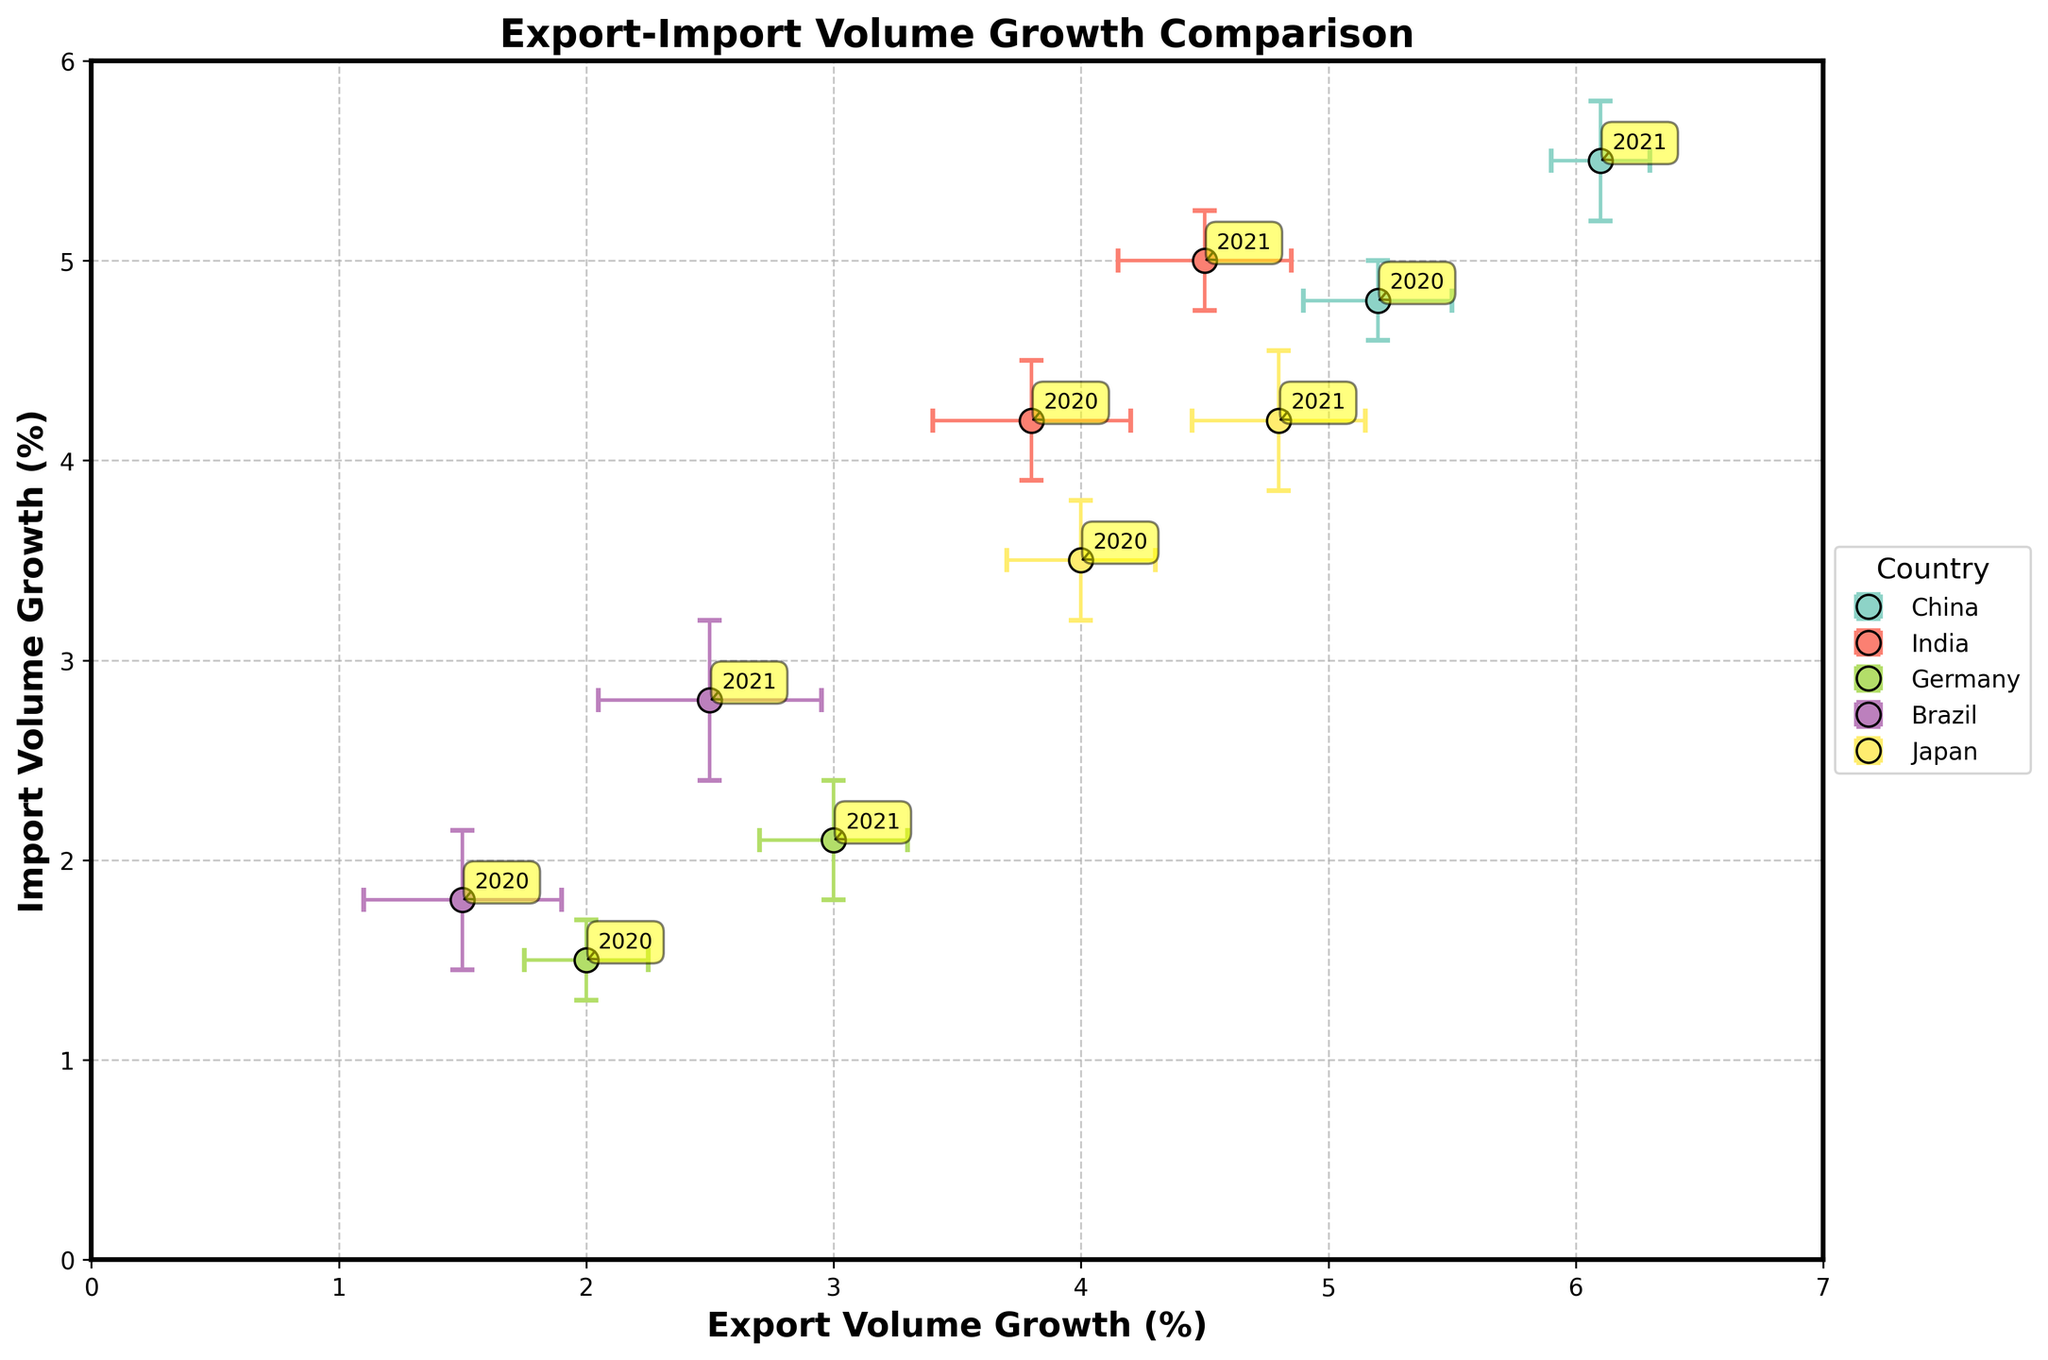What's the title of the figure? The title of the figure is located at the top center and reads "Export-Import Volume Growth Comparison."
Answer: Export-Import Volume Growth Comparison Which country has the highest export volume growth in 2021? By looking at the x-axis values labeled by the year 2021, China has an export volume growth of 6.1%. This is the highest value.
Answer: China Which country has the smallest import volume growth in 2020? By observing the y-axis values labeled 2020, Germany has the smallest import volume growth of 1.5%.
Answer: Germany What is the average import volume growth for Brazil across both years? The import volume growth for Brazil is 1.8% in 2020 and 2.8% in 2021. The average is (1.8 + 2.8) / 2 = 2.3%.
Answer: 2.3% For which country do the error bars overlap between 2020 and 2021 for export volume growth? Only Japan has the error bars for export volume growth overlap between 2020 (4.0 ± 0.3%) and 2021 (4.8 ± 0.35%) because the ranges (3.7%-4.3% and 4.45%-5.15%) overlap.
Answer: Japan How does the import volume growth of China in 2021 compare to that of India in 2021? China has an import volume growth of 5.5% in 2021, while India has 5.0%. Therefore, China's import volume growth is higher.
Answer: China has higher growth What is the difference between the maximum and minimum currency exchange rate fluctuations? The maximum currency exchange fluctuation is for Brazil in 2020 (3.5%), and the minimum is for Germany in 2021 (1.1%). The difference is 3.5% - 1.1% = 2.4%.
Answer: 2.4% Which country had a higher import volume growth in 2020, Brazil or Japan? In 2020, Brazil has an import volume growth of 1.8%, while Japan has 3.5%. Therefore, Japan had a higher import volume growth.
Answer: Japan How many countries are represented in the figure? Each country is denoted by different colored markers and labels. There are five unique countries represented (China, India, Germany, Brazil, and Japan).
Answer: 5 